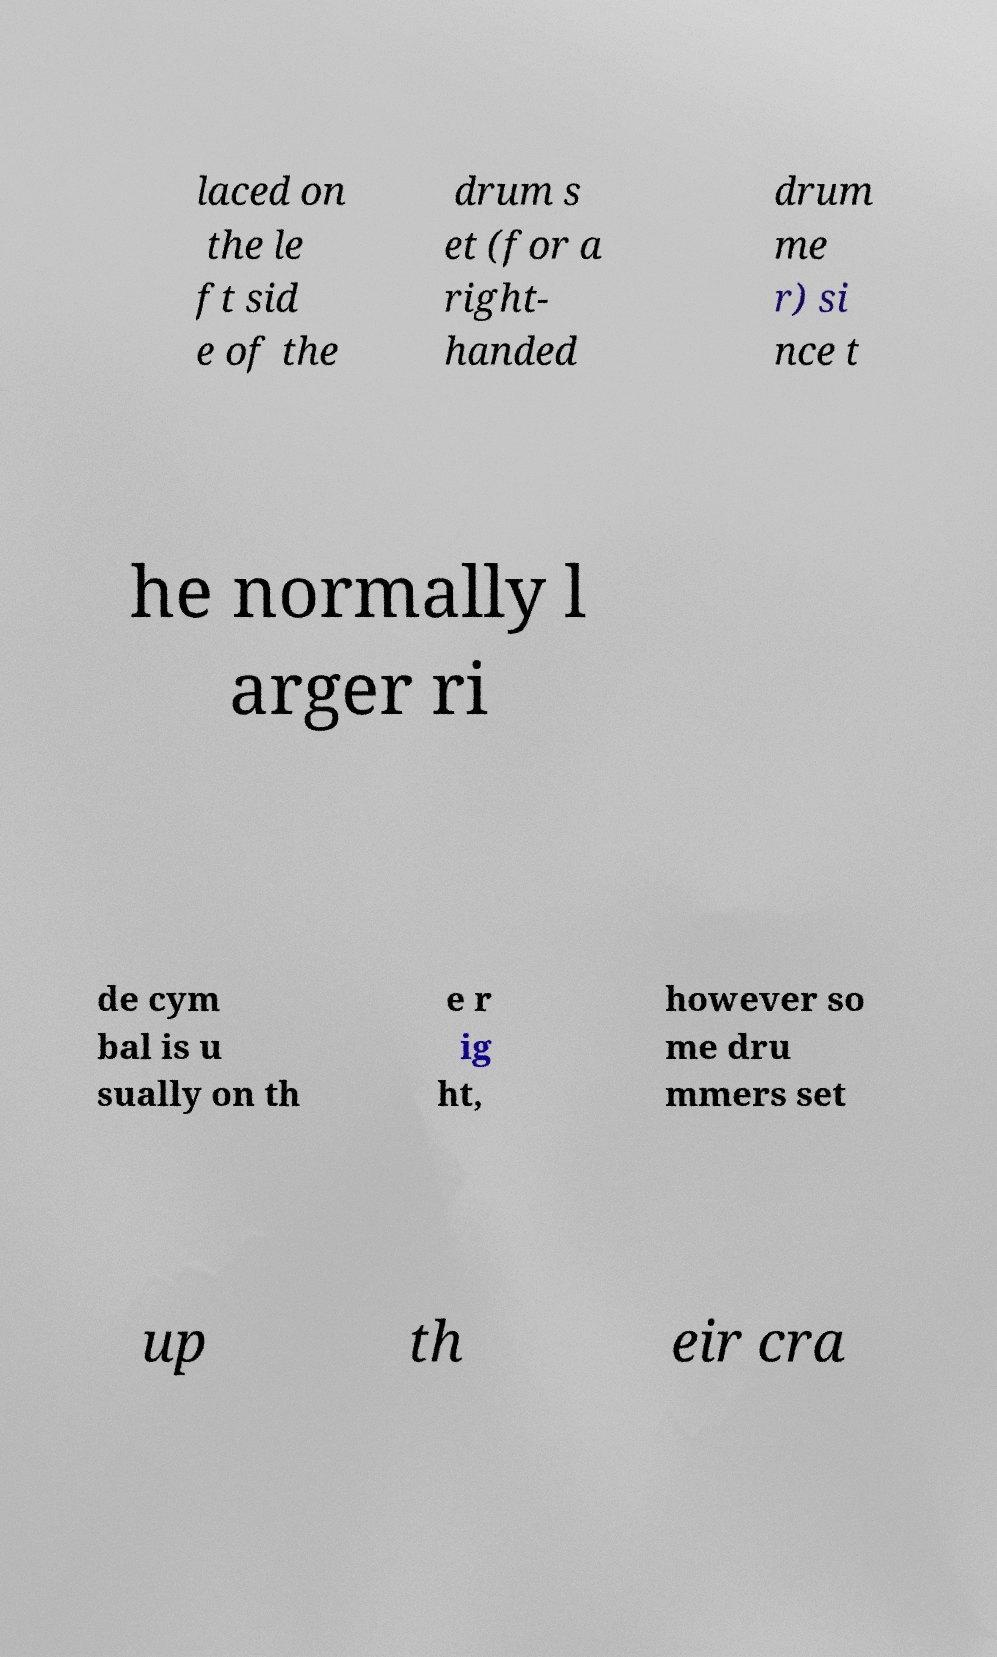For documentation purposes, I need the text within this image transcribed. Could you provide that? laced on the le ft sid e of the drum s et (for a right- handed drum me r) si nce t he normally l arger ri de cym bal is u sually on th e r ig ht, however so me dru mmers set up th eir cra 